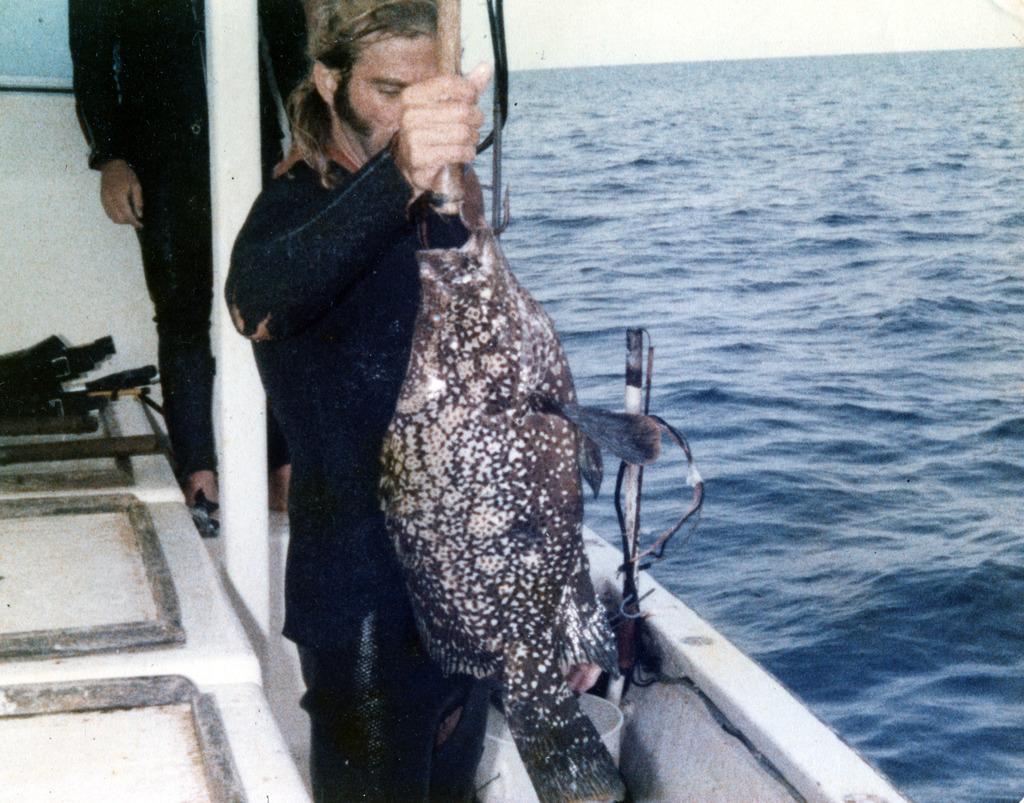Describe this image in one or two sentences. In this picture we can see two persons are standing in a boat, a person in the front is holding a fish, on the right side we can see water, there is the sky at the top of the picture. 